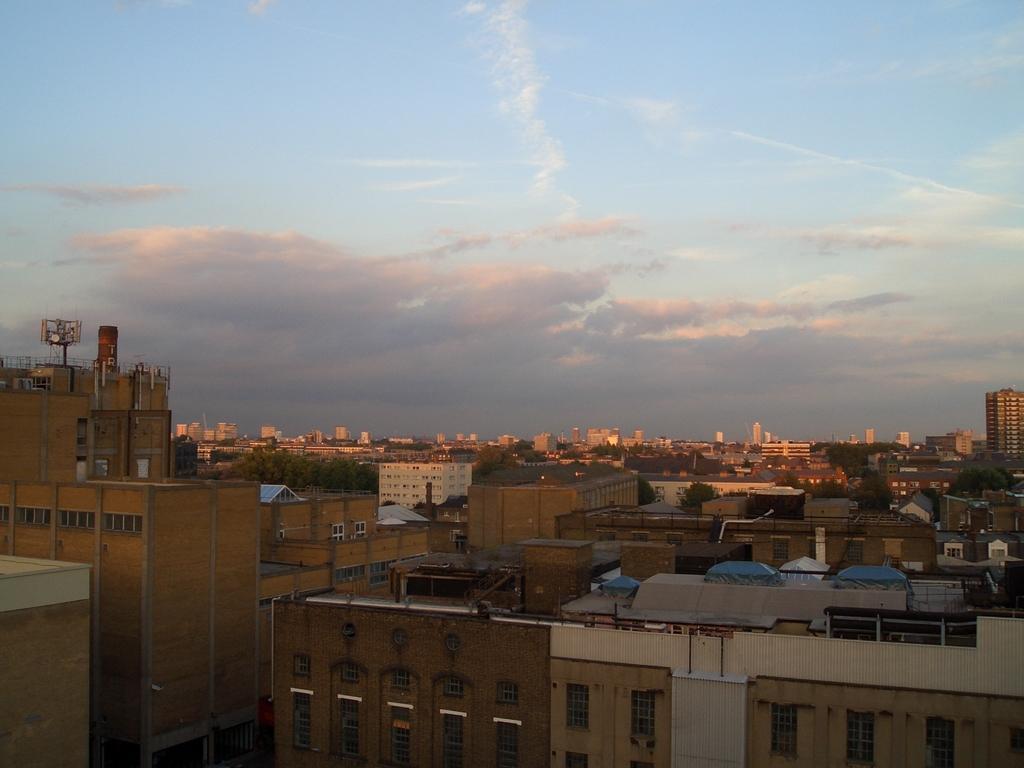Can you describe this image briefly? In this picture we can see few buildings, trees and clouds. 